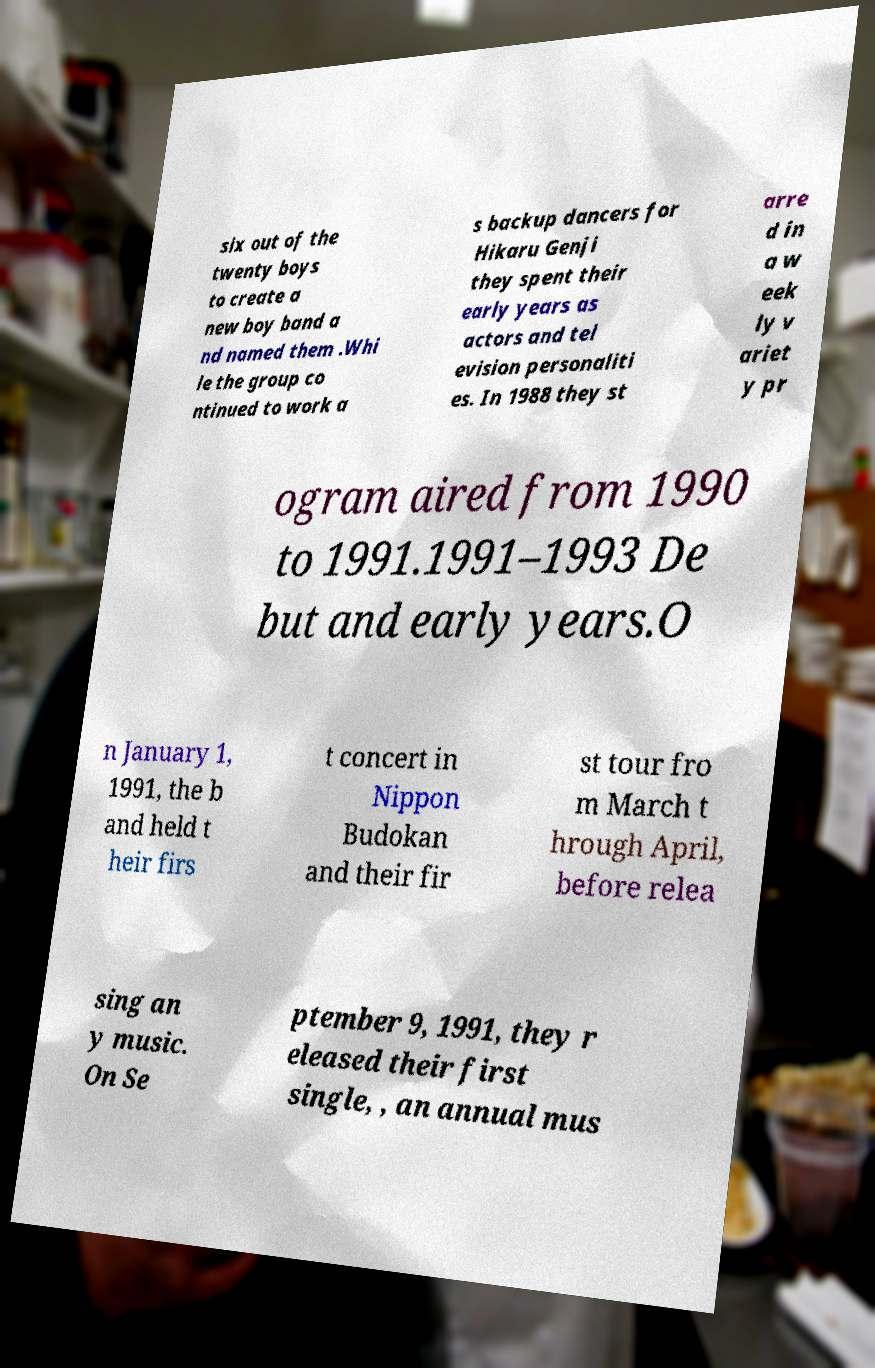Please identify and transcribe the text found in this image. six out of the twenty boys to create a new boy band a nd named them .Whi le the group co ntinued to work a s backup dancers for Hikaru Genji they spent their early years as actors and tel evision personaliti es. In 1988 they st arre d in a w eek ly v ariet y pr ogram aired from 1990 to 1991.1991–1993 De but and early years.O n January 1, 1991, the b and held t heir firs t concert in Nippon Budokan and their fir st tour fro m March t hrough April, before relea sing an y music. On Se ptember 9, 1991, they r eleased their first single, , an annual mus 